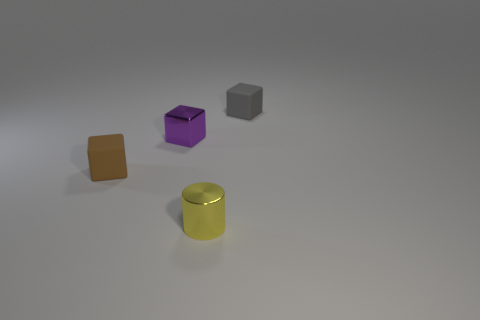Are there the same number of tiny purple blocks in front of the tiny brown matte cube and purple metal things that are in front of the small purple metallic cube?
Offer a terse response. Yes. There is a small metal thing to the left of the yellow cylinder; is its shape the same as the gray object?
Give a very brief answer. Yes. How many green objects are tiny spheres or tiny cubes?
Provide a short and direct response. 0. What material is the tiny gray object that is the same shape as the tiny purple metallic object?
Offer a very short reply. Rubber. There is a small matte object on the left side of the tiny gray block; what is its shape?
Offer a very short reply. Cube. Is there a small object made of the same material as the small purple cube?
Your answer should be very brief. Yes. How many spheres are either tiny blue objects or tiny gray objects?
Your response must be concise. 0. How many small yellow things have the same shape as the tiny purple thing?
Ensure brevity in your answer.  0. Is the number of cubes that are left of the metal cylinder greater than the number of blocks behind the brown cube?
Provide a short and direct response. No. There is a gray object that is the same size as the yellow object; what is it made of?
Keep it short and to the point. Rubber. 